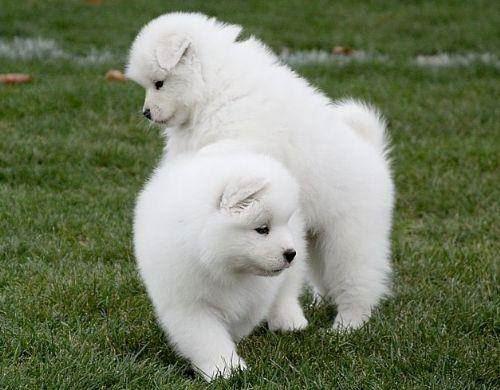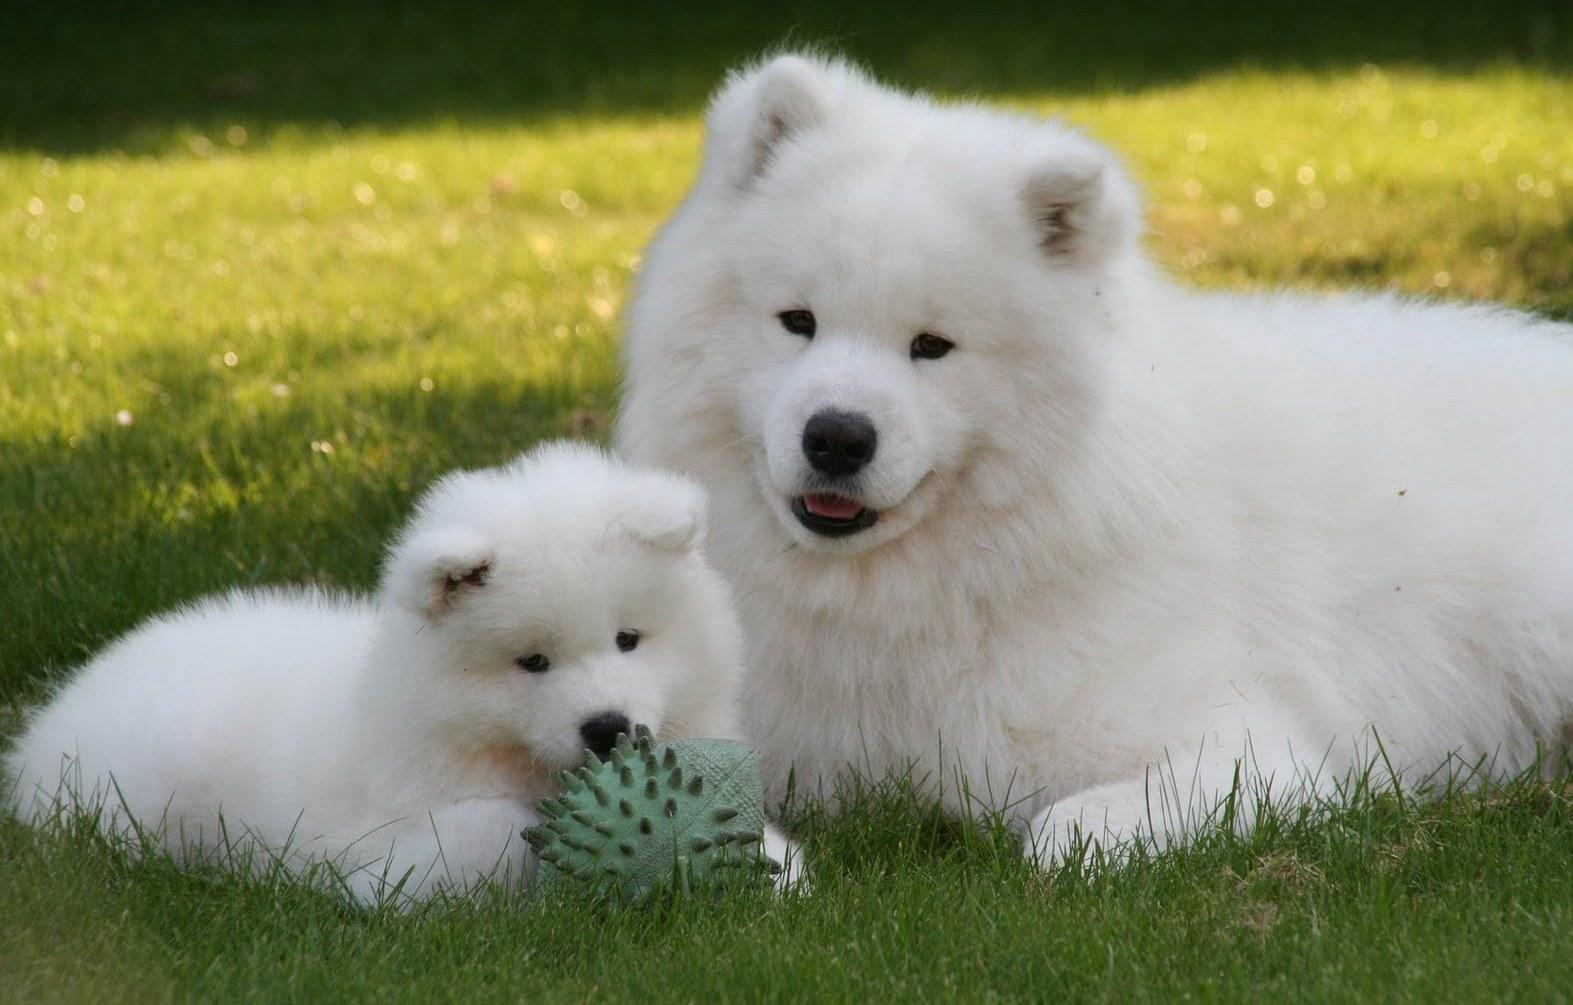The first image is the image on the left, the second image is the image on the right. Given the left and right images, does the statement "There are no more than three dogs" hold true? Answer yes or no. No. 